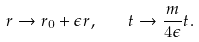<formula> <loc_0><loc_0><loc_500><loc_500>r \to r _ { 0 } + \epsilon r , \quad t \to \frac { m } { 4 \epsilon } t .</formula> 